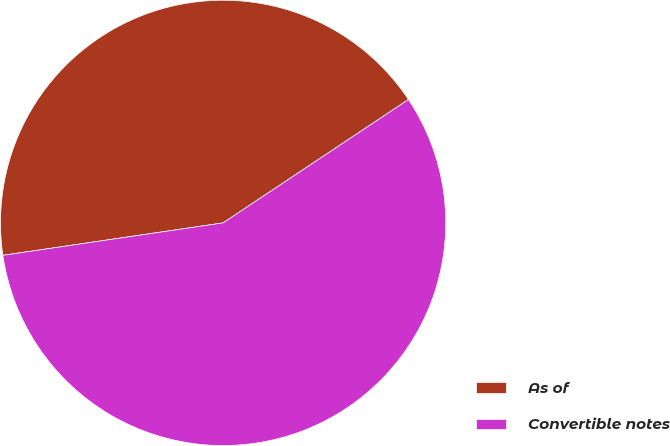Convert chart. <chart><loc_0><loc_0><loc_500><loc_500><pie_chart><fcel>As of<fcel>Convertible notes<nl><fcel>42.98%<fcel>57.02%<nl></chart> 